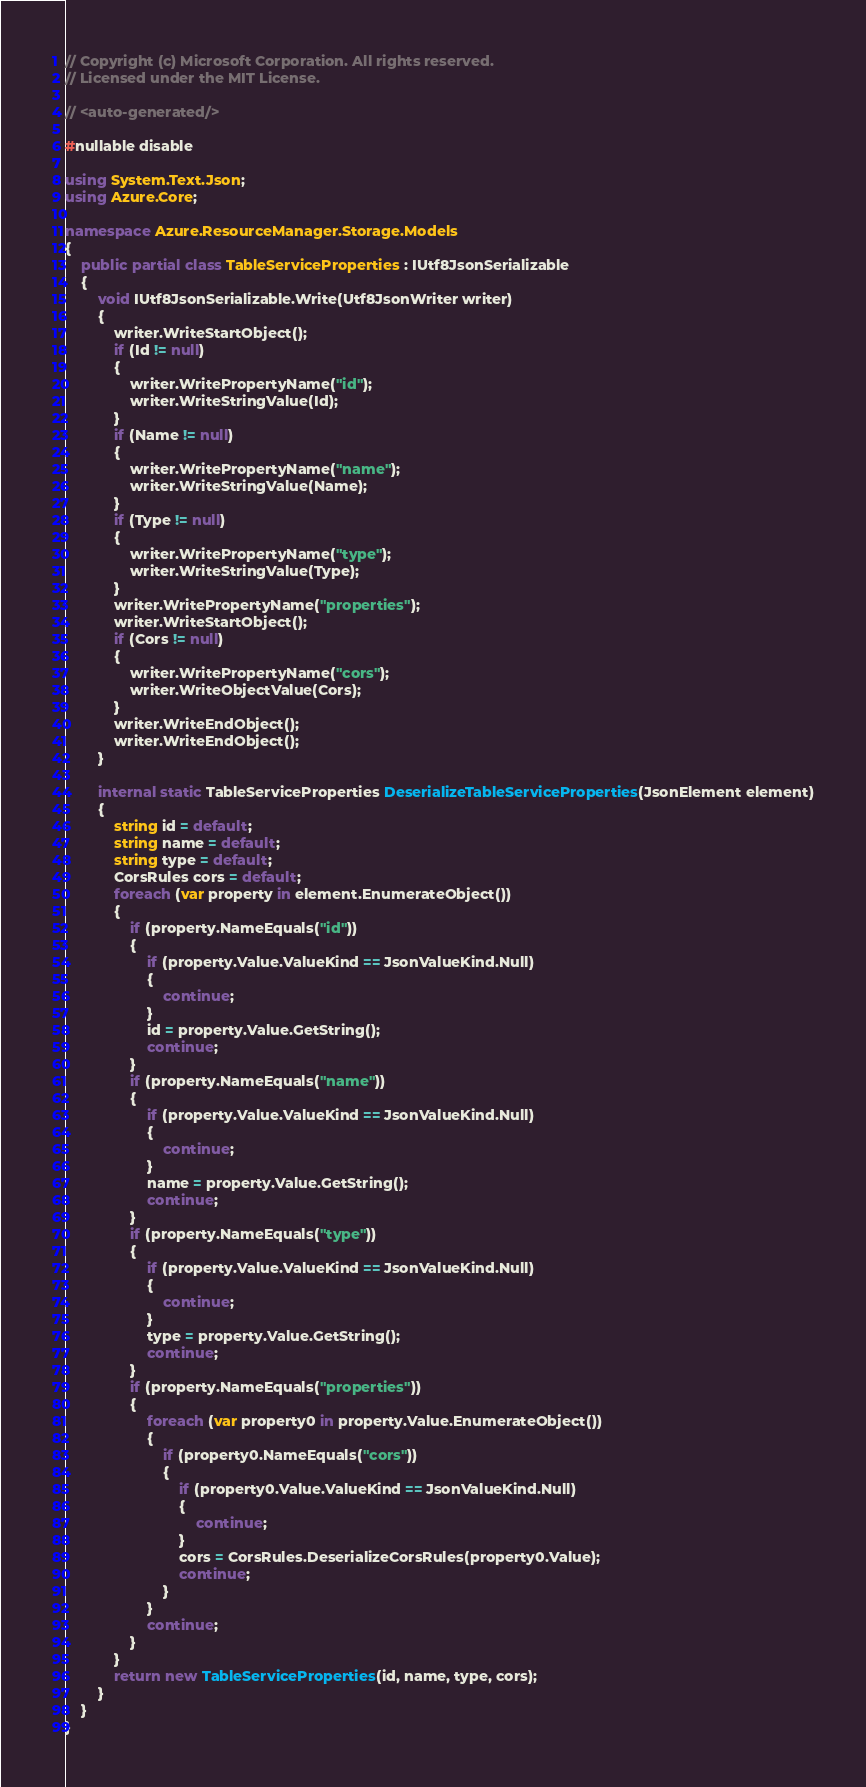Convert code to text. <code><loc_0><loc_0><loc_500><loc_500><_C#_>// Copyright (c) Microsoft Corporation. All rights reserved.
// Licensed under the MIT License.

// <auto-generated/>

#nullable disable

using System.Text.Json;
using Azure.Core;

namespace Azure.ResourceManager.Storage.Models
{
    public partial class TableServiceProperties : IUtf8JsonSerializable
    {
        void IUtf8JsonSerializable.Write(Utf8JsonWriter writer)
        {
            writer.WriteStartObject();
            if (Id != null)
            {
                writer.WritePropertyName("id");
                writer.WriteStringValue(Id);
            }
            if (Name != null)
            {
                writer.WritePropertyName("name");
                writer.WriteStringValue(Name);
            }
            if (Type != null)
            {
                writer.WritePropertyName("type");
                writer.WriteStringValue(Type);
            }
            writer.WritePropertyName("properties");
            writer.WriteStartObject();
            if (Cors != null)
            {
                writer.WritePropertyName("cors");
                writer.WriteObjectValue(Cors);
            }
            writer.WriteEndObject();
            writer.WriteEndObject();
        }

        internal static TableServiceProperties DeserializeTableServiceProperties(JsonElement element)
        {
            string id = default;
            string name = default;
            string type = default;
            CorsRules cors = default;
            foreach (var property in element.EnumerateObject())
            {
                if (property.NameEquals("id"))
                {
                    if (property.Value.ValueKind == JsonValueKind.Null)
                    {
                        continue;
                    }
                    id = property.Value.GetString();
                    continue;
                }
                if (property.NameEquals("name"))
                {
                    if (property.Value.ValueKind == JsonValueKind.Null)
                    {
                        continue;
                    }
                    name = property.Value.GetString();
                    continue;
                }
                if (property.NameEquals("type"))
                {
                    if (property.Value.ValueKind == JsonValueKind.Null)
                    {
                        continue;
                    }
                    type = property.Value.GetString();
                    continue;
                }
                if (property.NameEquals("properties"))
                {
                    foreach (var property0 in property.Value.EnumerateObject())
                    {
                        if (property0.NameEquals("cors"))
                        {
                            if (property0.Value.ValueKind == JsonValueKind.Null)
                            {
                                continue;
                            }
                            cors = CorsRules.DeserializeCorsRules(property0.Value);
                            continue;
                        }
                    }
                    continue;
                }
            }
            return new TableServiceProperties(id, name, type, cors);
        }
    }
}
</code> 